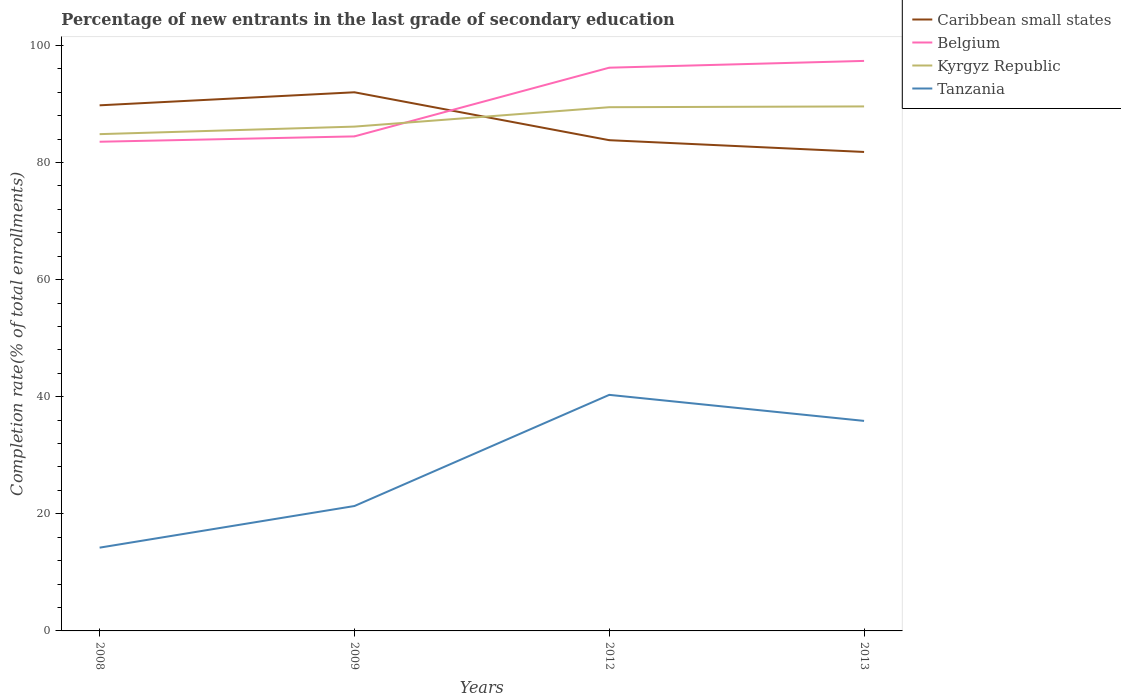Does the line corresponding to Caribbean small states intersect with the line corresponding to Tanzania?
Give a very brief answer. No. Is the number of lines equal to the number of legend labels?
Your answer should be very brief. Yes. Across all years, what is the maximum percentage of new entrants in Kyrgyz Republic?
Make the answer very short. 84.85. In which year was the percentage of new entrants in Caribbean small states maximum?
Your answer should be compact. 2013. What is the total percentage of new entrants in Caribbean small states in the graph?
Keep it short and to the point. 10.19. What is the difference between the highest and the second highest percentage of new entrants in Belgium?
Keep it short and to the point. 13.81. Is the percentage of new entrants in Caribbean small states strictly greater than the percentage of new entrants in Tanzania over the years?
Your response must be concise. No. How many years are there in the graph?
Offer a terse response. 4. What is the difference between two consecutive major ticks on the Y-axis?
Your answer should be compact. 20. What is the title of the graph?
Your answer should be compact. Percentage of new entrants in the last grade of secondary education. Does "Korea (Republic)" appear as one of the legend labels in the graph?
Your answer should be compact. No. What is the label or title of the X-axis?
Your response must be concise. Years. What is the label or title of the Y-axis?
Your response must be concise. Completion rate(% of total enrollments). What is the Completion rate(% of total enrollments) of Caribbean small states in 2008?
Ensure brevity in your answer.  89.77. What is the Completion rate(% of total enrollments) of Belgium in 2008?
Your response must be concise. 83.55. What is the Completion rate(% of total enrollments) of Kyrgyz Republic in 2008?
Your answer should be very brief. 84.85. What is the Completion rate(% of total enrollments) of Tanzania in 2008?
Give a very brief answer. 14.22. What is the Completion rate(% of total enrollments) of Caribbean small states in 2009?
Provide a short and direct response. 92. What is the Completion rate(% of total enrollments) of Belgium in 2009?
Ensure brevity in your answer.  84.47. What is the Completion rate(% of total enrollments) in Kyrgyz Republic in 2009?
Offer a terse response. 86.14. What is the Completion rate(% of total enrollments) in Tanzania in 2009?
Keep it short and to the point. 21.33. What is the Completion rate(% of total enrollments) of Caribbean small states in 2012?
Give a very brief answer. 83.82. What is the Completion rate(% of total enrollments) in Belgium in 2012?
Provide a succinct answer. 96.2. What is the Completion rate(% of total enrollments) in Kyrgyz Republic in 2012?
Keep it short and to the point. 89.45. What is the Completion rate(% of total enrollments) of Tanzania in 2012?
Your answer should be compact. 40.32. What is the Completion rate(% of total enrollments) in Caribbean small states in 2013?
Your answer should be compact. 81.81. What is the Completion rate(% of total enrollments) in Belgium in 2013?
Keep it short and to the point. 97.36. What is the Completion rate(% of total enrollments) of Kyrgyz Republic in 2013?
Your response must be concise. 89.59. What is the Completion rate(% of total enrollments) of Tanzania in 2013?
Make the answer very short. 35.87. Across all years, what is the maximum Completion rate(% of total enrollments) in Caribbean small states?
Your answer should be compact. 92. Across all years, what is the maximum Completion rate(% of total enrollments) of Belgium?
Offer a very short reply. 97.36. Across all years, what is the maximum Completion rate(% of total enrollments) of Kyrgyz Republic?
Offer a very short reply. 89.59. Across all years, what is the maximum Completion rate(% of total enrollments) of Tanzania?
Your answer should be compact. 40.32. Across all years, what is the minimum Completion rate(% of total enrollments) in Caribbean small states?
Offer a very short reply. 81.81. Across all years, what is the minimum Completion rate(% of total enrollments) in Belgium?
Keep it short and to the point. 83.55. Across all years, what is the minimum Completion rate(% of total enrollments) in Kyrgyz Republic?
Give a very brief answer. 84.85. Across all years, what is the minimum Completion rate(% of total enrollments) of Tanzania?
Give a very brief answer. 14.22. What is the total Completion rate(% of total enrollments) of Caribbean small states in the graph?
Your response must be concise. 347.41. What is the total Completion rate(% of total enrollments) of Belgium in the graph?
Your response must be concise. 361.58. What is the total Completion rate(% of total enrollments) of Kyrgyz Republic in the graph?
Provide a short and direct response. 350.03. What is the total Completion rate(% of total enrollments) in Tanzania in the graph?
Your answer should be very brief. 111.75. What is the difference between the Completion rate(% of total enrollments) in Caribbean small states in 2008 and that in 2009?
Offer a very short reply. -2.23. What is the difference between the Completion rate(% of total enrollments) in Belgium in 2008 and that in 2009?
Your answer should be compact. -0.91. What is the difference between the Completion rate(% of total enrollments) in Kyrgyz Republic in 2008 and that in 2009?
Keep it short and to the point. -1.29. What is the difference between the Completion rate(% of total enrollments) of Tanzania in 2008 and that in 2009?
Your answer should be compact. -7.11. What is the difference between the Completion rate(% of total enrollments) of Caribbean small states in 2008 and that in 2012?
Give a very brief answer. 5.96. What is the difference between the Completion rate(% of total enrollments) of Belgium in 2008 and that in 2012?
Offer a terse response. -12.65. What is the difference between the Completion rate(% of total enrollments) in Kyrgyz Republic in 2008 and that in 2012?
Your answer should be very brief. -4.6. What is the difference between the Completion rate(% of total enrollments) of Tanzania in 2008 and that in 2012?
Provide a succinct answer. -26.1. What is the difference between the Completion rate(% of total enrollments) in Caribbean small states in 2008 and that in 2013?
Give a very brief answer. 7.96. What is the difference between the Completion rate(% of total enrollments) of Belgium in 2008 and that in 2013?
Offer a very short reply. -13.81. What is the difference between the Completion rate(% of total enrollments) in Kyrgyz Republic in 2008 and that in 2013?
Ensure brevity in your answer.  -4.74. What is the difference between the Completion rate(% of total enrollments) of Tanzania in 2008 and that in 2013?
Provide a succinct answer. -21.65. What is the difference between the Completion rate(% of total enrollments) of Caribbean small states in 2009 and that in 2012?
Provide a succinct answer. 8.18. What is the difference between the Completion rate(% of total enrollments) in Belgium in 2009 and that in 2012?
Your response must be concise. -11.74. What is the difference between the Completion rate(% of total enrollments) of Kyrgyz Republic in 2009 and that in 2012?
Your response must be concise. -3.31. What is the difference between the Completion rate(% of total enrollments) in Tanzania in 2009 and that in 2012?
Make the answer very short. -18.99. What is the difference between the Completion rate(% of total enrollments) of Caribbean small states in 2009 and that in 2013?
Give a very brief answer. 10.19. What is the difference between the Completion rate(% of total enrollments) of Belgium in 2009 and that in 2013?
Your answer should be compact. -12.89. What is the difference between the Completion rate(% of total enrollments) in Kyrgyz Republic in 2009 and that in 2013?
Keep it short and to the point. -3.45. What is the difference between the Completion rate(% of total enrollments) of Tanzania in 2009 and that in 2013?
Your answer should be very brief. -14.54. What is the difference between the Completion rate(% of total enrollments) of Caribbean small states in 2012 and that in 2013?
Ensure brevity in your answer.  2.01. What is the difference between the Completion rate(% of total enrollments) of Belgium in 2012 and that in 2013?
Your response must be concise. -1.16. What is the difference between the Completion rate(% of total enrollments) of Kyrgyz Republic in 2012 and that in 2013?
Offer a very short reply. -0.13. What is the difference between the Completion rate(% of total enrollments) in Tanzania in 2012 and that in 2013?
Ensure brevity in your answer.  4.45. What is the difference between the Completion rate(% of total enrollments) of Caribbean small states in 2008 and the Completion rate(% of total enrollments) of Belgium in 2009?
Offer a very short reply. 5.31. What is the difference between the Completion rate(% of total enrollments) in Caribbean small states in 2008 and the Completion rate(% of total enrollments) in Kyrgyz Republic in 2009?
Make the answer very short. 3.64. What is the difference between the Completion rate(% of total enrollments) in Caribbean small states in 2008 and the Completion rate(% of total enrollments) in Tanzania in 2009?
Make the answer very short. 68.44. What is the difference between the Completion rate(% of total enrollments) in Belgium in 2008 and the Completion rate(% of total enrollments) in Kyrgyz Republic in 2009?
Your answer should be compact. -2.58. What is the difference between the Completion rate(% of total enrollments) in Belgium in 2008 and the Completion rate(% of total enrollments) in Tanzania in 2009?
Give a very brief answer. 62.22. What is the difference between the Completion rate(% of total enrollments) in Kyrgyz Republic in 2008 and the Completion rate(% of total enrollments) in Tanzania in 2009?
Keep it short and to the point. 63.52. What is the difference between the Completion rate(% of total enrollments) in Caribbean small states in 2008 and the Completion rate(% of total enrollments) in Belgium in 2012?
Offer a very short reply. -6.43. What is the difference between the Completion rate(% of total enrollments) of Caribbean small states in 2008 and the Completion rate(% of total enrollments) of Kyrgyz Republic in 2012?
Offer a very short reply. 0.32. What is the difference between the Completion rate(% of total enrollments) in Caribbean small states in 2008 and the Completion rate(% of total enrollments) in Tanzania in 2012?
Keep it short and to the point. 49.45. What is the difference between the Completion rate(% of total enrollments) in Belgium in 2008 and the Completion rate(% of total enrollments) in Kyrgyz Republic in 2012?
Provide a succinct answer. -5.9. What is the difference between the Completion rate(% of total enrollments) in Belgium in 2008 and the Completion rate(% of total enrollments) in Tanzania in 2012?
Offer a very short reply. 43.23. What is the difference between the Completion rate(% of total enrollments) of Kyrgyz Republic in 2008 and the Completion rate(% of total enrollments) of Tanzania in 2012?
Ensure brevity in your answer.  44.53. What is the difference between the Completion rate(% of total enrollments) in Caribbean small states in 2008 and the Completion rate(% of total enrollments) in Belgium in 2013?
Provide a short and direct response. -7.59. What is the difference between the Completion rate(% of total enrollments) in Caribbean small states in 2008 and the Completion rate(% of total enrollments) in Kyrgyz Republic in 2013?
Your answer should be compact. 0.19. What is the difference between the Completion rate(% of total enrollments) in Caribbean small states in 2008 and the Completion rate(% of total enrollments) in Tanzania in 2013?
Offer a very short reply. 53.9. What is the difference between the Completion rate(% of total enrollments) in Belgium in 2008 and the Completion rate(% of total enrollments) in Kyrgyz Republic in 2013?
Your answer should be very brief. -6.03. What is the difference between the Completion rate(% of total enrollments) in Belgium in 2008 and the Completion rate(% of total enrollments) in Tanzania in 2013?
Your answer should be very brief. 47.68. What is the difference between the Completion rate(% of total enrollments) of Kyrgyz Republic in 2008 and the Completion rate(% of total enrollments) of Tanzania in 2013?
Keep it short and to the point. 48.98. What is the difference between the Completion rate(% of total enrollments) in Caribbean small states in 2009 and the Completion rate(% of total enrollments) in Belgium in 2012?
Keep it short and to the point. -4.2. What is the difference between the Completion rate(% of total enrollments) in Caribbean small states in 2009 and the Completion rate(% of total enrollments) in Kyrgyz Republic in 2012?
Give a very brief answer. 2.55. What is the difference between the Completion rate(% of total enrollments) in Caribbean small states in 2009 and the Completion rate(% of total enrollments) in Tanzania in 2012?
Provide a succinct answer. 51.68. What is the difference between the Completion rate(% of total enrollments) of Belgium in 2009 and the Completion rate(% of total enrollments) of Kyrgyz Republic in 2012?
Your response must be concise. -4.99. What is the difference between the Completion rate(% of total enrollments) of Belgium in 2009 and the Completion rate(% of total enrollments) of Tanzania in 2012?
Give a very brief answer. 44.15. What is the difference between the Completion rate(% of total enrollments) in Kyrgyz Republic in 2009 and the Completion rate(% of total enrollments) in Tanzania in 2012?
Give a very brief answer. 45.82. What is the difference between the Completion rate(% of total enrollments) in Caribbean small states in 2009 and the Completion rate(% of total enrollments) in Belgium in 2013?
Your response must be concise. -5.36. What is the difference between the Completion rate(% of total enrollments) in Caribbean small states in 2009 and the Completion rate(% of total enrollments) in Kyrgyz Republic in 2013?
Your answer should be very brief. 2.41. What is the difference between the Completion rate(% of total enrollments) of Caribbean small states in 2009 and the Completion rate(% of total enrollments) of Tanzania in 2013?
Keep it short and to the point. 56.13. What is the difference between the Completion rate(% of total enrollments) of Belgium in 2009 and the Completion rate(% of total enrollments) of Kyrgyz Republic in 2013?
Give a very brief answer. -5.12. What is the difference between the Completion rate(% of total enrollments) of Belgium in 2009 and the Completion rate(% of total enrollments) of Tanzania in 2013?
Offer a very short reply. 48.59. What is the difference between the Completion rate(% of total enrollments) in Kyrgyz Republic in 2009 and the Completion rate(% of total enrollments) in Tanzania in 2013?
Provide a short and direct response. 50.26. What is the difference between the Completion rate(% of total enrollments) of Caribbean small states in 2012 and the Completion rate(% of total enrollments) of Belgium in 2013?
Offer a terse response. -13.54. What is the difference between the Completion rate(% of total enrollments) of Caribbean small states in 2012 and the Completion rate(% of total enrollments) of Kyrgyz Republic in 2013?
Keep it short and to the point. -5.77. What is the difference between the Completion rate(% of total enrollments) in Caribbean small states in 2012 and the Completion rate(% of total enrollments) in Tanzania in 2013?
Provide a succinct answer. 47.94. What is the difference between the Completion rate(% of total enrollments) in Belgium in 2012 and the Completion rate(% of total enrollments) in Kyrgyz Republic in 2013?
Keep it short and to the point. 6.62. What is the difference between the Completion rate(% of total enrollments) in Belgium in 2012 and the Completion rate(% of total enrollments) in Tanzania in 2013?
Your answer should be compact. 60.33. What is the difference between the Completion rate(% of total enrollments) in Kyrgyz Republic in 2012 and the Completion rate(% of total enrollments) in Tanzania in 2013?
Keep it short and to the point. 53.58. What is the average Completion rate(% of total enrollments) in Caribbean small states per year?
Provide a succinct answer. 86.85. What is the average Completion rate(% of total enrollments) in Belgium per year?
Offer a terse response. 90.4. What is the average Completion rate(% of total enrollments) of Kyrgyz Republic per year?
Provide a short and direct response. 87.51. What is the average Completion rate(% of total enrollments) of Tanzania per year?
Provide a short and direct response. 27.94. In the year 2008, what is the difference between the Completion rate(% of total enrollments) of Caribbean small states and Completion rate(% of total enrollments) of Belgium?
Your response must be concise. 6.22. In the year 2008, what is the difference between the Completion rate(% of total enrollments) in Caribbean small states and Completion rate(% of total enrollments) in Kyrgyz Republic?
Ensure brevity in your answer.  4.92. In the year 2008, what is the difference between the Completion rate(% of total enrollments) in Caribbean small states and Completion rate(% of total enrollments) in Tanzania?
Keep it short and to the point. 75.55. In the year 2008, what is the difference between the Completion rate(% of total enrollments) of Belgium and Completion rate(% of total enrollments) of Kyrgyz Republic?
Ensure brevity in your answer.  -1.3. In the year 2008, what is the difference between the Completion rate(% of total enrollments) in Belgium and Completion rate(% of total enrollments) in Tanzania?
Make the answer very short. 69.33. In the year 2008, what is the difference between the Completion rate(% of total enrollments) of Kyrgyz Republic and Completion rate(% of total enrollments) of Tanzania?
Offer a very short reply. 70.63. In the year 2009, what is the difference between the Completion rate(% of total enrollments) in Caribbean small states and Completion rate(% of total enrollments) in Belgium?
Keep it short and to the point. 7.53. In the year 2009, what is the difference between the Completion rate(% of total enrollments) of Caribbean small states and Completion rate(% of total enrollments) of Kyrgyz Republic?
Your answer should be compact. 5.86. In the year 2009, what is the difference between the Completion rate(% of total enrollments) in Caribbean small states and Completion rate(% of total enrollments) in Tanzania?
Give a very brief answer. 70.67. In the year 2009, what is the difference between the Completion rate(% of total enrollments) of Belgium and Completion rate(% of total enrollments) of Kyrgyz Republic?
Provide a short and direct response. -1.67. In the year 2009, what is the difference between the Completion rate(% of total enrollments) of Belgium and Completion rate(% of total enrollments) of Tanzania?
Your response must be concise. 63.13. In the year 2009, what is the difference between the Completion rate(% of total enrollments) of Kyrgyz Republic and Completion rate(% of total enrollments) of Tanzania?
Make the answer very short. 64.8. In the year 2012, what is the difference between the Completion rate(% of total enrollments) of Caribbean small states and Completion rate(% of total enrollments) of Belgium?
Keep it short and to the point. -12.38. In the year 2012, what is the difference between the Completion rate(% of total enrollments) in Caribbean small states and Completion rate(% of total enrollments) in Kyrgyz Republic?
Your answer should be compact. -5.63. In the year 2012, what is the difference between the Completion rate(% of total enrollments) in Caribbean small states and Completion rate(% of total enrollments) in Tanzania?
Your answer should be compact. 43.5. In the year 2012, what is the difference between the Completion rate(% of total enrollments) in Belgium and Completion rate(% of total enrollments) in Kyrgyz Republic?
Offer a terse response. 6.75. In the year 2012, what is the difference between the Completion rate(% of total enrollments) of Belgium and Completion rate(% of total enrollments) of Tanzania?
Provide a short and direct response. 55.88. In the year 2012, what is the difference between the Completion rate(% of total enrollments) of Kyrgyz Republic and Completion rate(% of total enrollments) of Tanzania?
Give a very brief answer. 49.13. In the year 2013, what is the difference between the Completion rate(% of total enrollments) of Caribbean small states and Completion rate(% of total enrollments) of Belgium?
Ensure brevity in your answer.  -15.55. In the year 2013, what is the difference between the Completion rate(% of total enrollments) of Caribbean small states and Completion rate(% of total enrollments) of Kyrgyz Republic?
Offer a very short reply. -7.78. In the year 2013, what is the difference between the Completion rate(% of total enrollments) in Caribbean small states and Completion rate(% of total enrollments) in Tanzania?
Offer a very short reply. 45.94. In the year 2013, what is the difference between the Completion rate(% of total enrollments) in Belgium and Completion rate(% of total enrollments) in Kyrgyz Republic?
Your response must be concise. 7.77. In the year 2013, what is the difference between the Completion rate(% of total enrollments) in Belgium and Completion rate(% of total enrollments) in Tanzania?
Your response must be concise. 61.49. In the year 2013, what is the difference between the Completion rate(% of total enrollments) of Kyrgyz Republic and Completion rate(% of total enrollments) of Tanzania?
Your answer should be very brief. 53.71. What is the ratio of the Completion rate(% of total enrollments) of Caribbean small states in 2008 to that in 2009?
Ensure brevity in your answer.  0.98. What is the ratio of the Completion rate(% of total enrollments) in Kyrgyz Republic in 2008 to that in 2009?
Your answer should be compact. 0.99. What is the ratio of the Completion rate(% of total enrollments) in Tanzania in 2008 to that in 2009?
Provide a short and direct response. 0.67. What is the ratio of the Completion rate(% of total enrollments) in Caribbean small states in 2008 to that in 2012?
Make the answer very short. 1.07. What is the ratio of the Completion rate(% of total enrollments) in Belgium in 2008 to that in 2012?
Provide a succinct answer. 0.87. What is the ratio of the Completion rate(% of total enrollments) of Kyrgyz Republic in 2008 to that in 2012?
Offer a terse response. 0.95. What is the ratio of the Completion rate(% of total enrollments) of Tanzania in 2008 to that in 2012?
Make the answer very short. 0.35. What is the ratio of the Completion rate(% of total enrollments) in Caribbean small states in 2008 to that in 2013?
Your answer should be very brief. 1.1. What is the ratio of the Completion rate(% of total enrollments) in Belgium in 2008 to that in 2013?
Keep it short and to the point. 0.86. What is the ratio of the Completion rate(% of total enrollments) of Kyrgyz Republic in 2008 to that in 2013?
Offer a very short reply. 0.95. What is the ratio of the Completion rate(% of total enrollments) of Tanzania in 2008 to that in 2013?
Provide a succinct answer. 0.4. What is the ratio of the Completion rate(% of total enrollments) in Caribbean small states in 2009 to that in 2012?
Give a very brief answer. 1.1. What is the ratio of the Completion rate(% of total enrollments) in Belgium in 2009 to that in 2012?
Provide a succinct answer. 0.88. What is the ratio of the Completion rate(% of total enrollments) of Kyrgyz Republic in 2009 to that in 2012?
Provide a succinct answer. 0.96. What is the ratio of the Completion rate(% of total enrollments) in Tanzania in 2009 to that in 2012?
Ensure brevity in your answer.  0.53. What is the ratio of the Completion rate(% of total enrollments) in Caribbean small states in 2009 to that in 2013?
Give a very brief answer. 1.12. What is the ratio of the Completion rate(% of total enrollments) in Belgium in 2009 to that in 2013?
Offer a terse response. 0.87. What is the ratio of the Completion rate(% of total enrollments) of Kyrgyz Republic in 2009 to that in 2013?
Give a very brief answer. 0.96. What is the ratio of the Completion rate(% of total enrollments) in Tanzania in 2009 to that in 2013?
Provide a short and direct response. 0.59. What is the ratio of the Completion rate(% of total enrollments) in Caribbean small states in 2012 to that in 2013?
Make the answer very short. 1.02. What is the ratio of the Completion rate(% of total enrollments) of Kyrgyz Republic in 2012 to that in 2013?
Your response must be concise. 1. What is the ratio of the Completion rate(% of total enrollments) of Tanzania in 2012 to that in 2013?
Give a very brief answer. 1.12. What is the difference between the highest and the second highest Completion rate(% of total enrollments) of Caribbean small states?
Your answer should be compact. 2.23. What is the difference between the highest and the second highest Completion rate(% of total enrollments) in Belgium?
Offer a very short reply. 1.16. What is the difference between the highest and the second highest Completion rate(% of total enrollments) of Kyrgyz Republic?
Your response must be concise. 0.13. What is the difference between the highest and the second highest Completion rate(% of total enrollments) in Tanzania?
Provide a short and direct response. 4.45. What is the difference between the highest and the lowest Completion rate(% of total enrollments) of Caribbean small states?
Keep it short and to the point. 10.19. What is the difference between the highest and the lowest Completion rate(% of total enrollments) of Belgium?
Make the answer very short. 13.81. What is the difference between the highest and the lowest Completion rate(% of total enrollments) in Kyrgyz Republic?
Your answer should be very brief. 4.74. What is the difference between the highest and the lowest Completion rate(% of total enrollments) of Tanzania?
Provide a short and direct response. 26.1. 